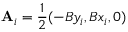Convert formula to latex. <formula><loc_0><loc_0><loc_500><loc_500>A _ { i } = \frac { 1 } { 2 } ( - B y _ { i } , B x _ { i } , 0 )</formula> 